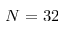Convert formula to latex. <formula><loc_0><loc_0><loc_500><loc_500>N = 3 2</formula> 